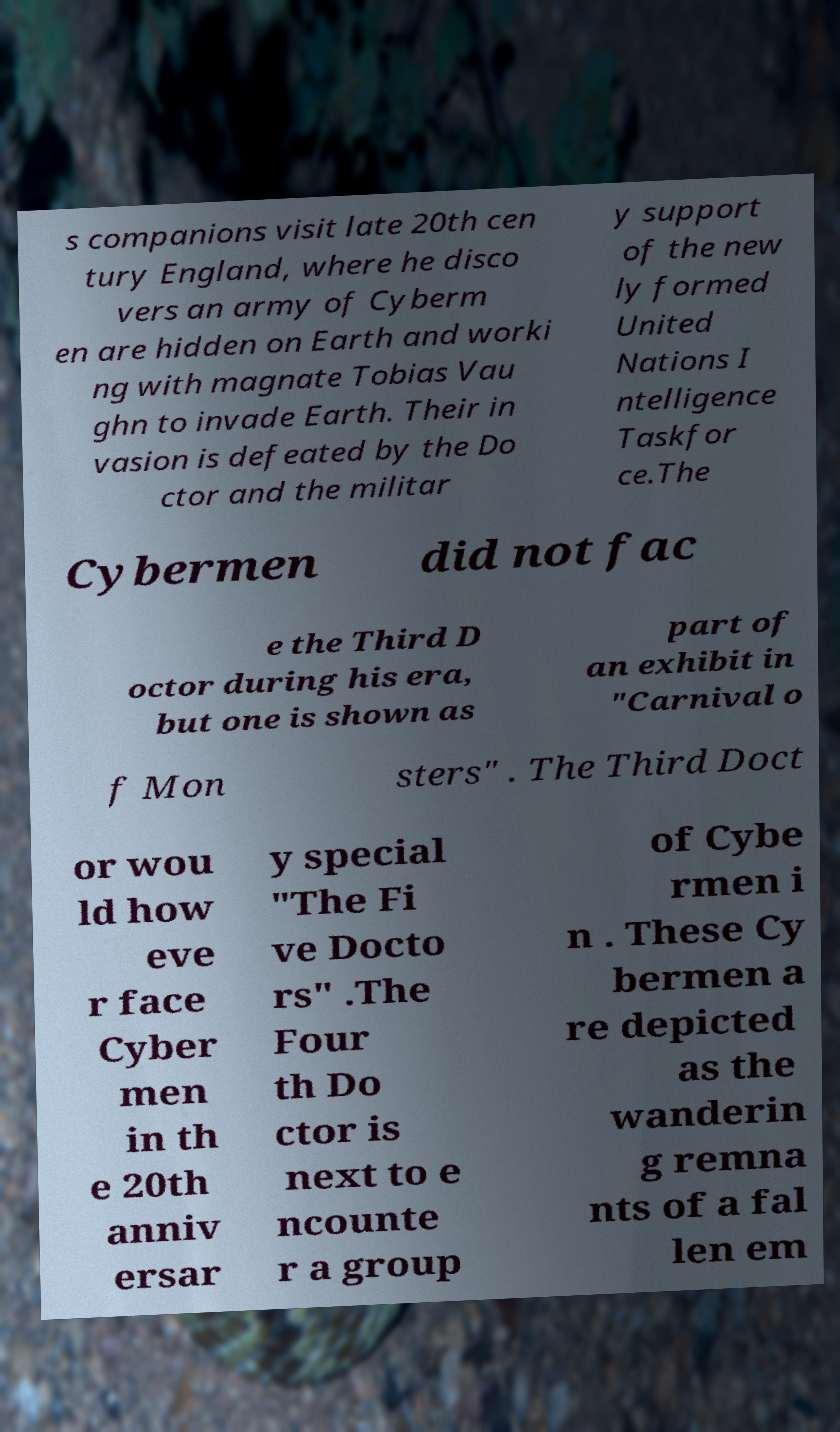Could you extract and type out the text from this image? s companions visit late 20th cen tury England, where he disco vers an army of Cyberm en are hidden on Earth and worki ng with magnate Tobias Vau ghn to invade Earth. Their in vasion is defeated by the Do ctor and the militar y support of the new ly formed United Nations I ntelligence Taskfor ce.The Cybermen did not fac e the Third D octor during his era, but one is shown as part of an exhibit in "Carnival o f Mon sters" . The Third Doct or wou ld how eve r face Cyber men in th e 20th anniv ersar y special "The Fi ve Docto rs" .The Four th Do ctor is next to e ncounte r a group of Cybe rmen i n . These Cy bermen a re depicted as the wanderin g remna nts of a fal len em 